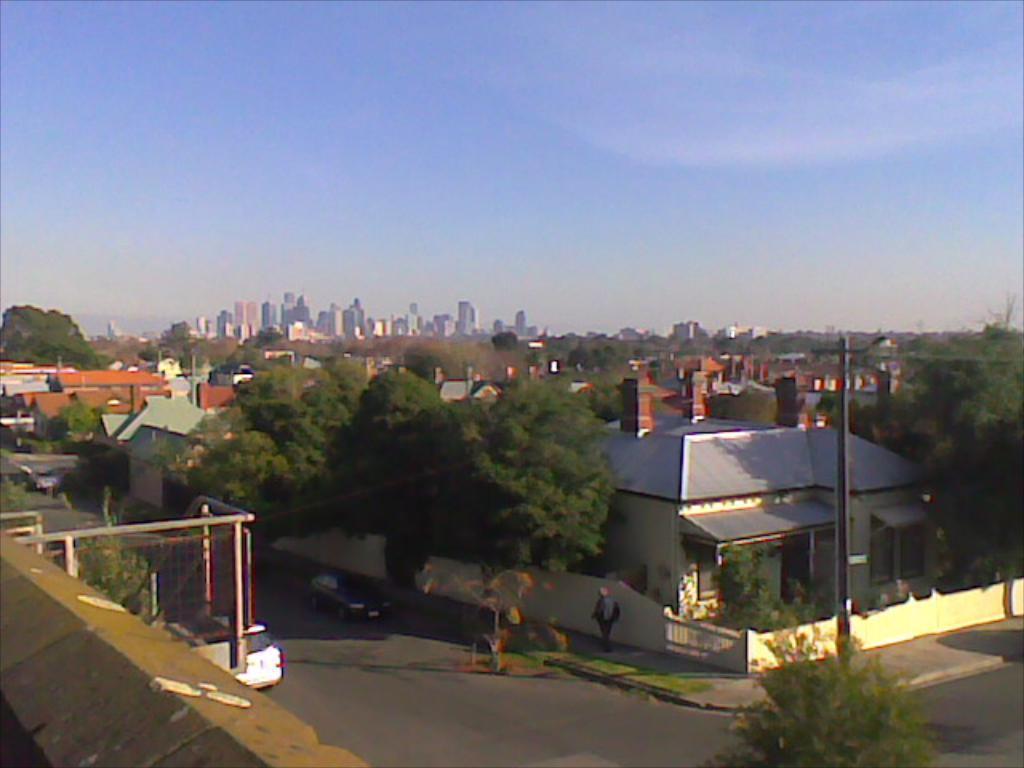Can you describe this image briefly? In this picture I can see there is a street and there are buildings here. There are trees and vehicles are parked in the street and I can see there is a person walking on the walk way. In the backdrop there are some more buildings and the sky is clear. 